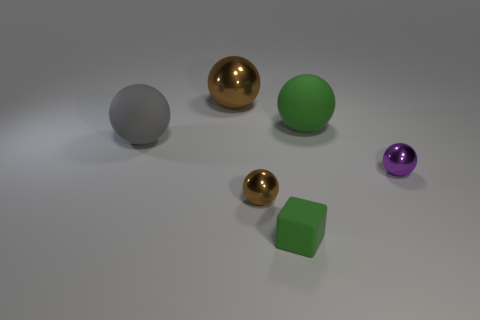Subtract all gray balls. How many balls are left? 4 Subtract all large gray matte balls. How many balls are left? 4 Subtract all red balls. Subtract all gray cylinders. How many balls are left? 5 Add 3 large gray balls. How many objects exist? 9 Subtract all balls. How many objects are left? 1 Subtract 0 yellow balls. How many objects are left? 6 Subtract all tiny brown balls. Subtract all green spheres. How many objects are left? 4 Add 2 tiny things. How many tiny things are left? 5 Add 2 purple metallic things. How many purple metallic things exist? 3 